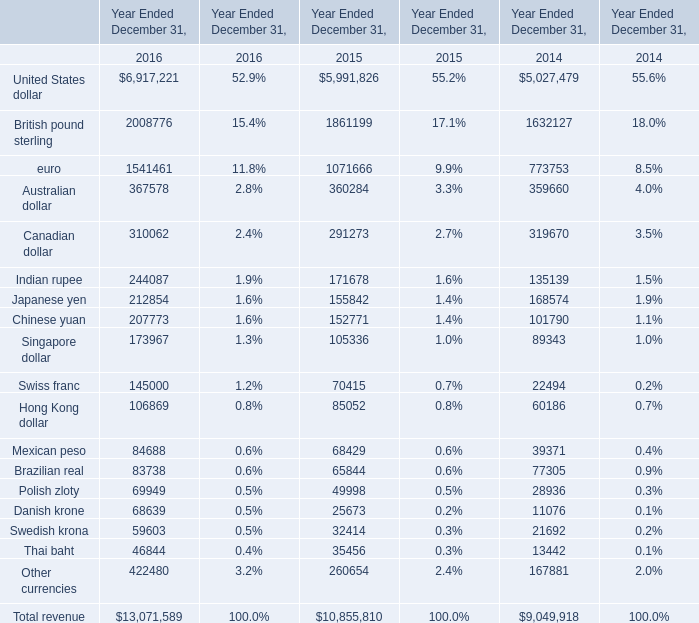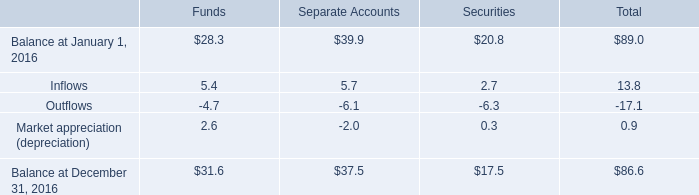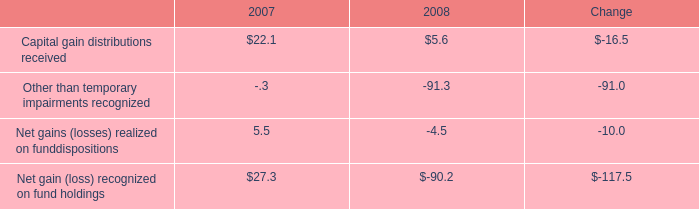What is the sum of Australian dollar, Canadian dollar and Indian rupee in 2016？ ? 
Computations: ((367578 + 310062) + 244087)
Answer: 921727.0. 